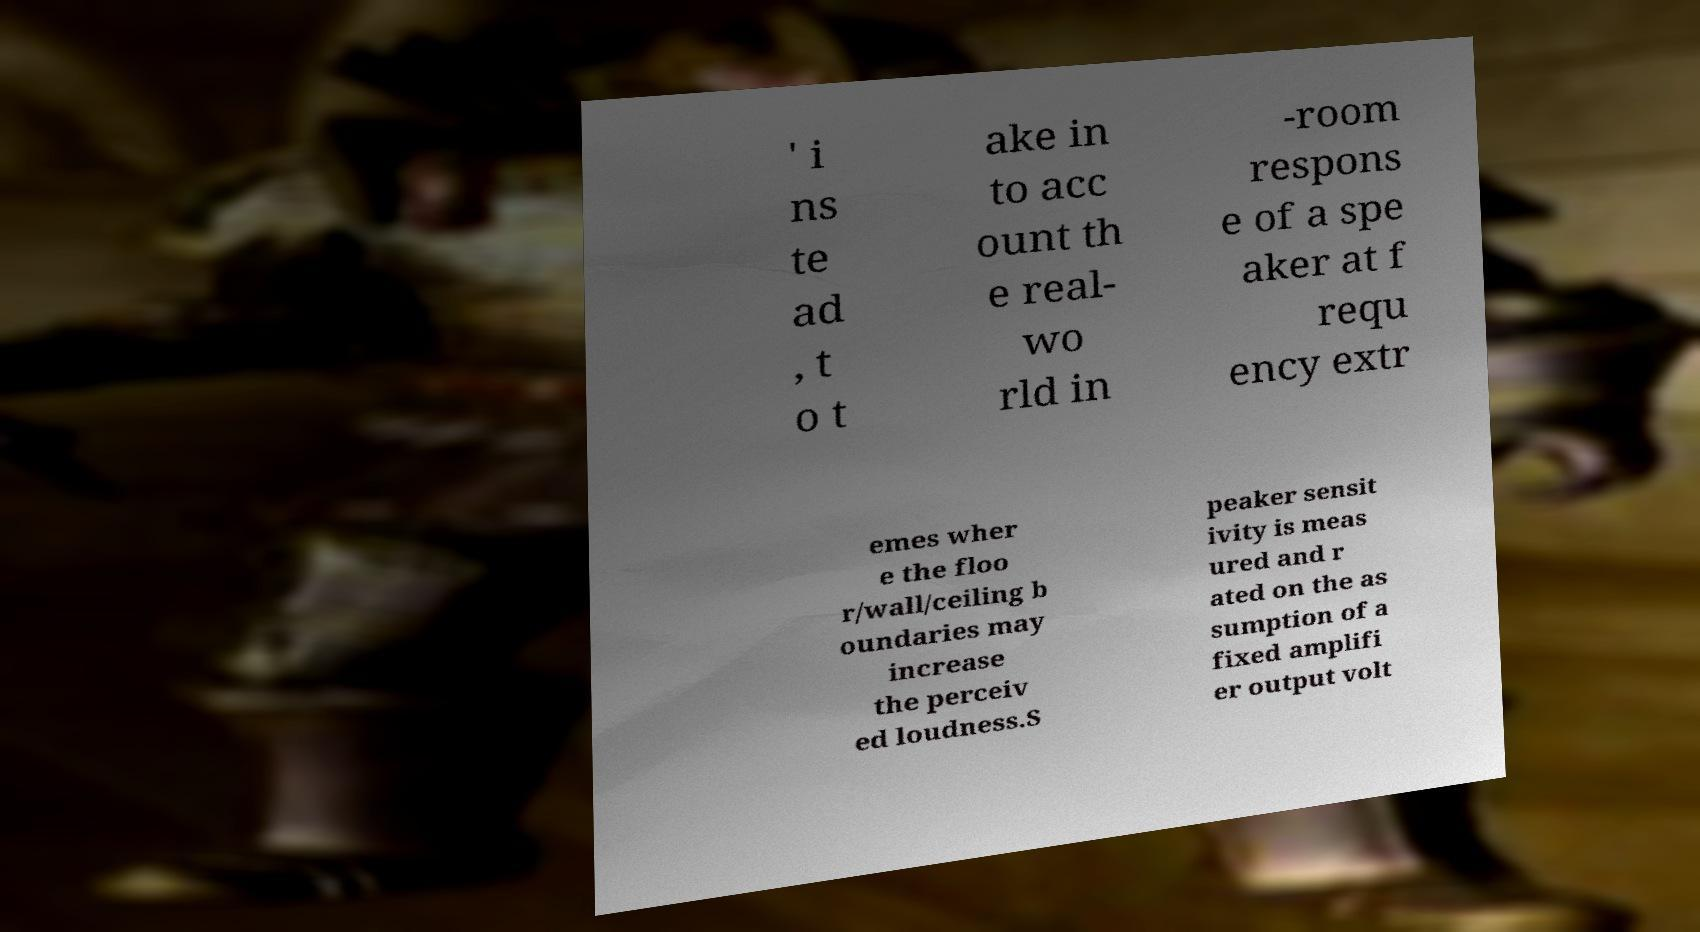Could you extract and type out the text from this image? ' i ns te ad , t o t ake in to acc ount th e real- wo rld in -room respons e of a spe aker at f requ ency extr emes wher e the floo r/wall/ceiling b oundaries may increase the perceiv ed loudness.S peaker sensit ivity is meas ured and r ated on the as sumption of a fixed amplifi er output volt 